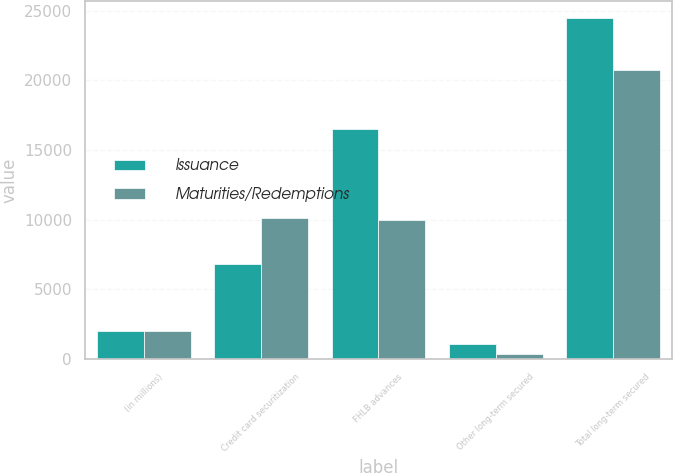Convert chart to OTSL. <chart><loc_0><loc_0><loc_500><loc_500><stacked_bar_chart><ecel><fcel>(in millions)<fcel>Credit card securitization<fcel>FHLB advances<fcel>Other long-term secured<fcel>Total long-term secured<nl><fcel>Issuance<fcel>2015<fcel>6807<fcel>16550<fcel>1105<fcel>24462<nl><fcel>Maturities/Redemptions<fcel>2015<fcel>10130<fcel>9960<fcel>383<fcel>20721<nl></chart> 